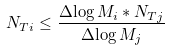<formula> <loc_0><loc_0><loc_500><loc_500>N _ { T i } \leq \frac { \Delta { \log M _ { i } } * N _ { T j } } { \Delta { \log M _ { j } } }</formula> 